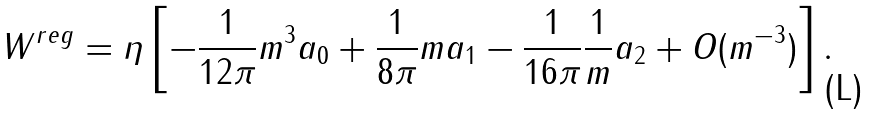<formula> <loc_0><loc_0><loc_500><loc_500>W ^ { r e g } = \eta \left [ - { \frac { 1 } { 1 2 \pi } } m ^ { 3 } a _ { 0 } + { \frac { 1 } { 8 \pi } } m a _ { 1 } - { \frac { 1 } { 1 6 \pi } } { \frac { 1 } { m } } a _ { 2 } + O ( m ^ { - 3 } ) \right ] .</formula> 